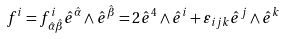Convert formula to latex. <formula><loc_0><loc_0><loc_500><loc_500>f ^ { i } = f ^ { i } _ { \, { \hat { \alpha } } { \hat { \beta } } } { \hat { e } } ^ { \hat { \alpha } } \wedge { \hat { e } } ^ { \hat { \beta } } = 2 { \hat { e } } ^ { 4 } \wedge { \hat { e } } ^ { i } + \varepsilon _ { i j k } { \hat { e } } ^ { j } \wedge { \hat { e } } ^ { k }</formula> 